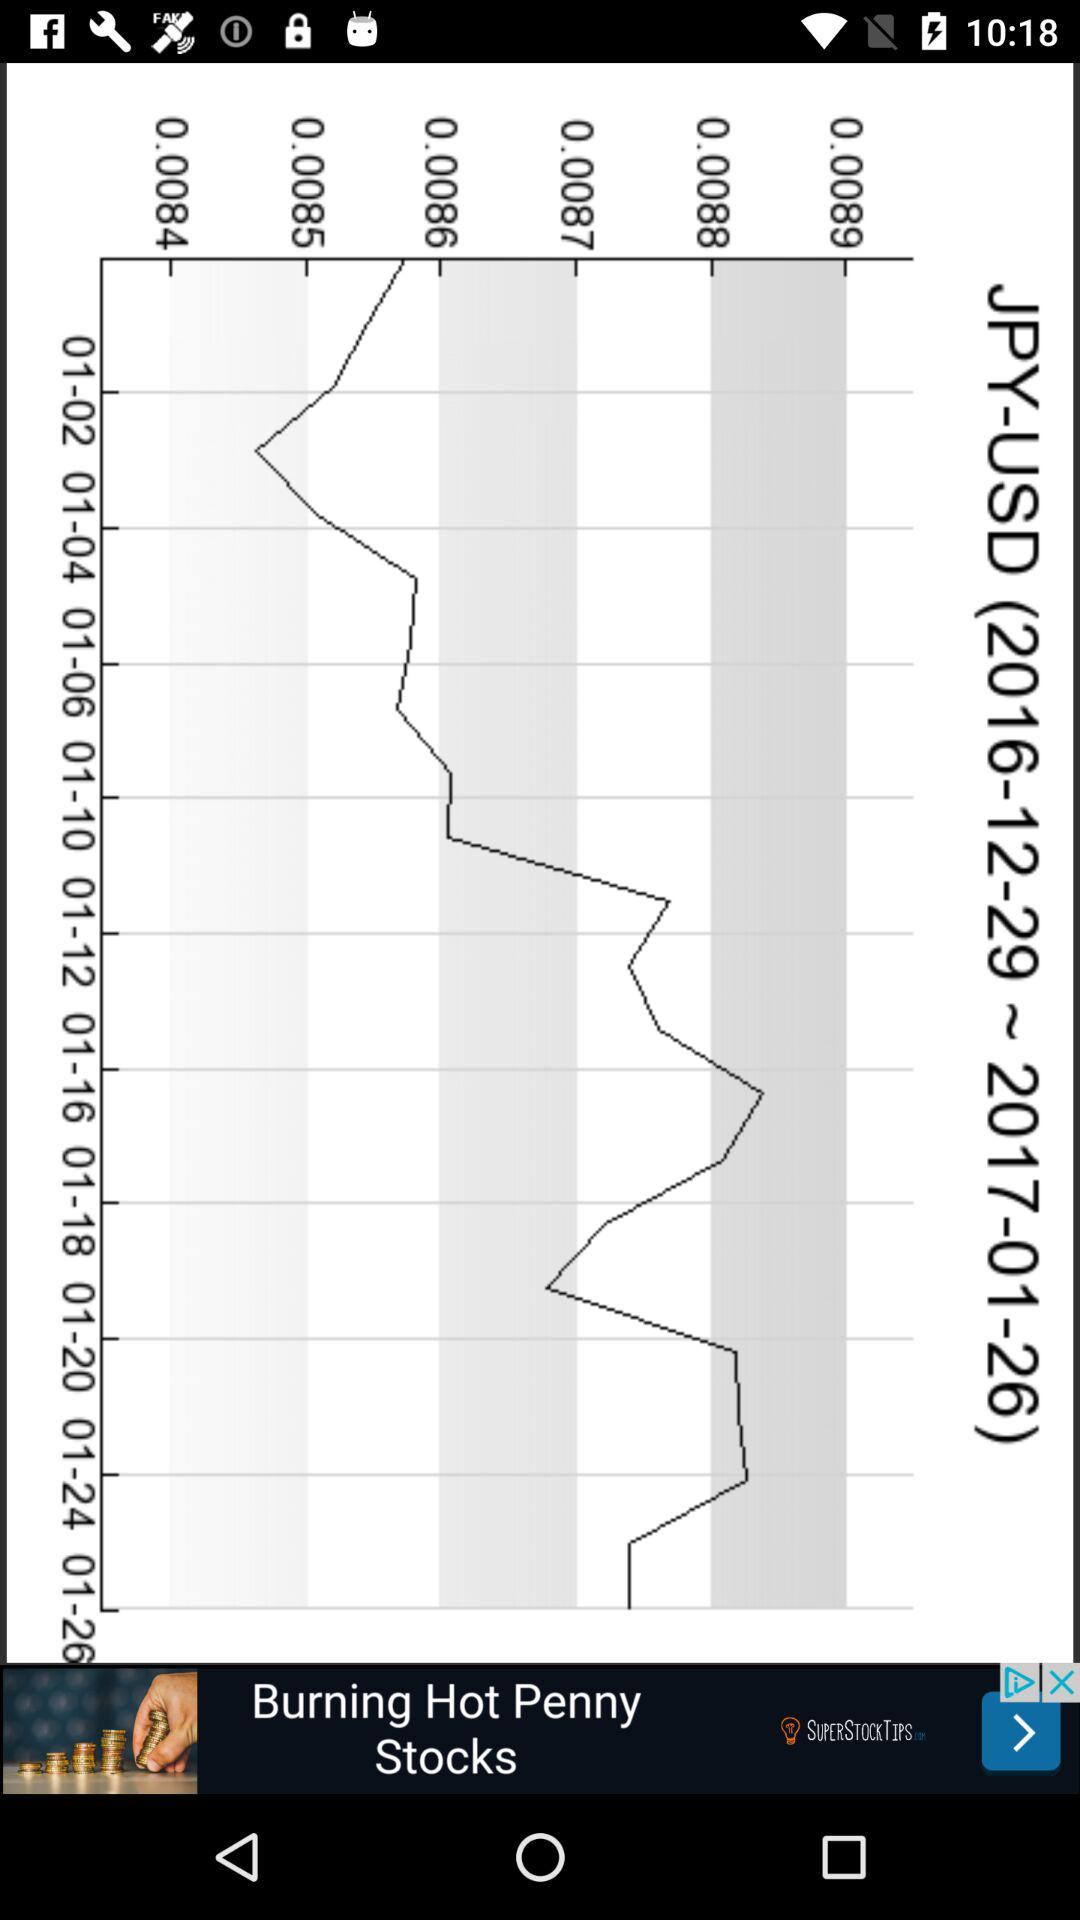What is the mentioned date range? The mentioned date range is from December 29, 2016 to January 26, 2017. 